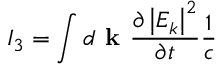Convert formula to latex. <formula><loc_0><loc_0><loc_500><loc_500>I _ { 3 } = \int d k \frac { \partial \left | E _ { k } \right | ^ { 2 } } { \partial t } \frac { 1 } { c }</formula> 